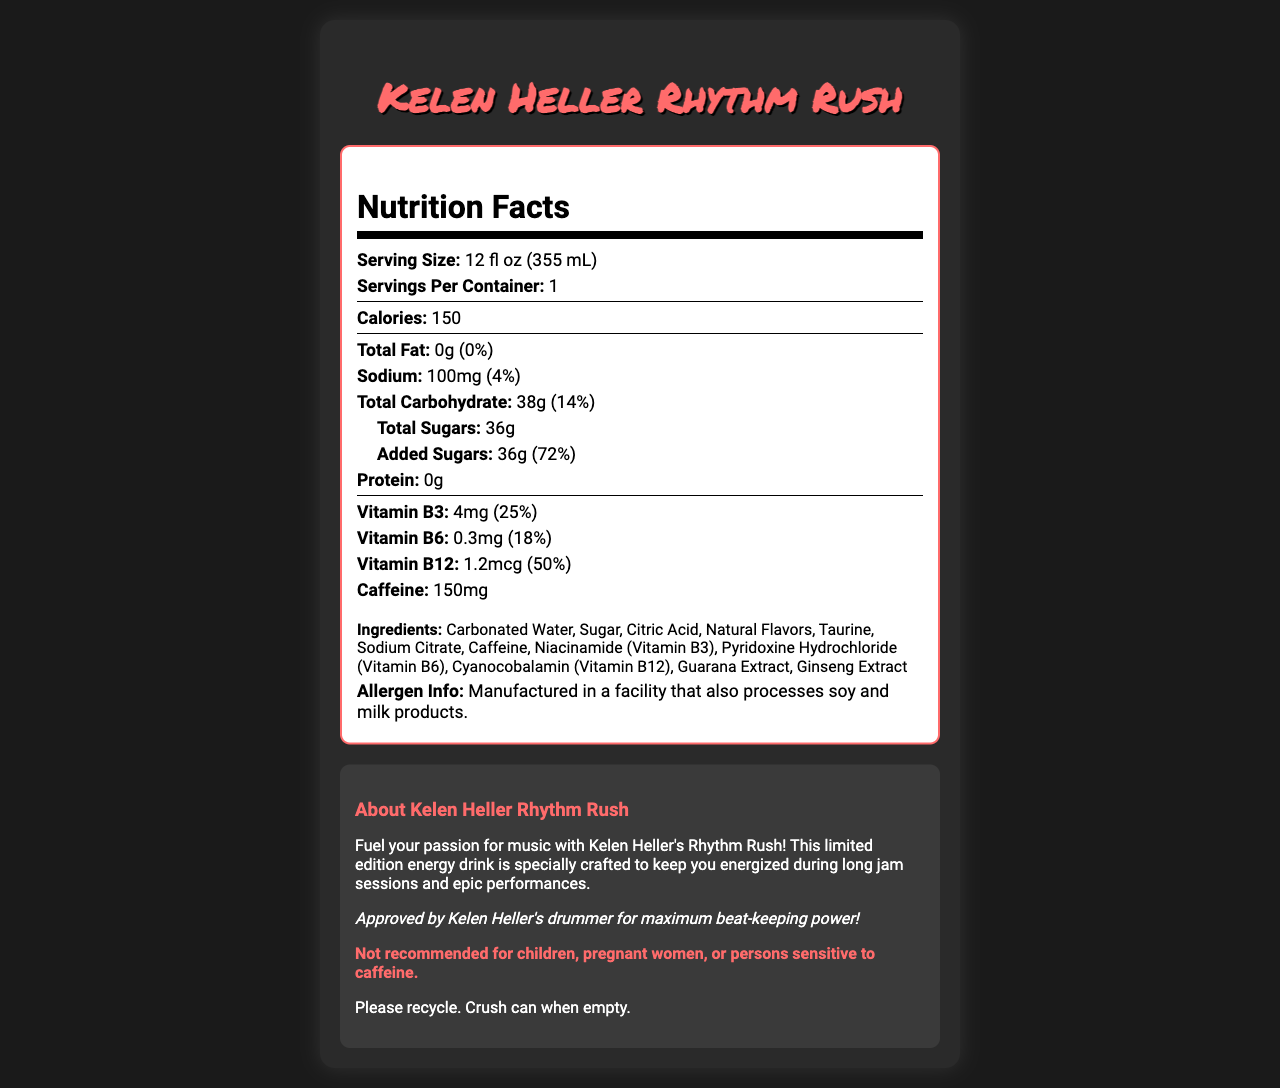what is the serving size? The serving size is stated directly in the Nutrition Facts Label under "Serving Size".
Answer: 12 fl oz (355 mL) how many calories are in one serving? The number of calories per serving is listed in the document under "Calories".
Answer: 150 calories what is the total carbohydrate content? The total carbohydrate content is listed as 38g in the document, under "Total Carbohydrate".
Answer: 38g what percentage of the daily value is Vitamin B12? The document specifies that the Vitamin B12 content is 1.2mcg, which represents 50% of the daily value.
Answer: 50% what is the caffeine content in "Kelen Heller Rhythm Rush"? The caffeine content is clearly stated in the Nutrition Facts Label as 150mg.
Answer: 150mg how many servings are there per container? A. 1 B. 2 C. 3 The document specifies that there is 1 serving per container.
Answer: A which ingredient is listed first? A. Sugar B. Citric Acid C. Carbonated Water D. Taurine Ingredients are listed in the order they appear, and Carbonated Water is the first ingredient on the list.
Answer: C Is there any protein in "Kelen Heller Rhythm Rush"? The document states that the protein content is 0g.
Answer: No Is this energy drink recommended for children? The warning in the document clearly states that it is not recommended for children.
Answer: No summarize the main idea of the document The document provides essential details about the energy drink's nutritional content, ingredients, and usage instructions.
Answer: The document is a Nutrition Facts Label for "Kelen Heller Rhythm Rush", a limited edition energy drink endorsed by the band Kelen Heller. It includes detailed nutritional information, a list of ingredients, allergen info, and a warning about caffeine sensitivity. The energy drink contains 150 calories, 150mg of caffeine, and various B vitamins. how does the drink help with long jam sessions and performances? The document states that the drink is crafted for energy during long jam sessions and performances but does not provide specific details on how it achieves this effect.
Answer: Not enough information 